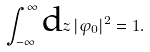Convert formula to latex. <formula><loc_0><loc_0><loc_500><loc_500>\int _ { - \infty } ^ { \infty } \text {d} z \, | \varphi _ { 0 } | ^ { 2 } = 1 .</formula> 